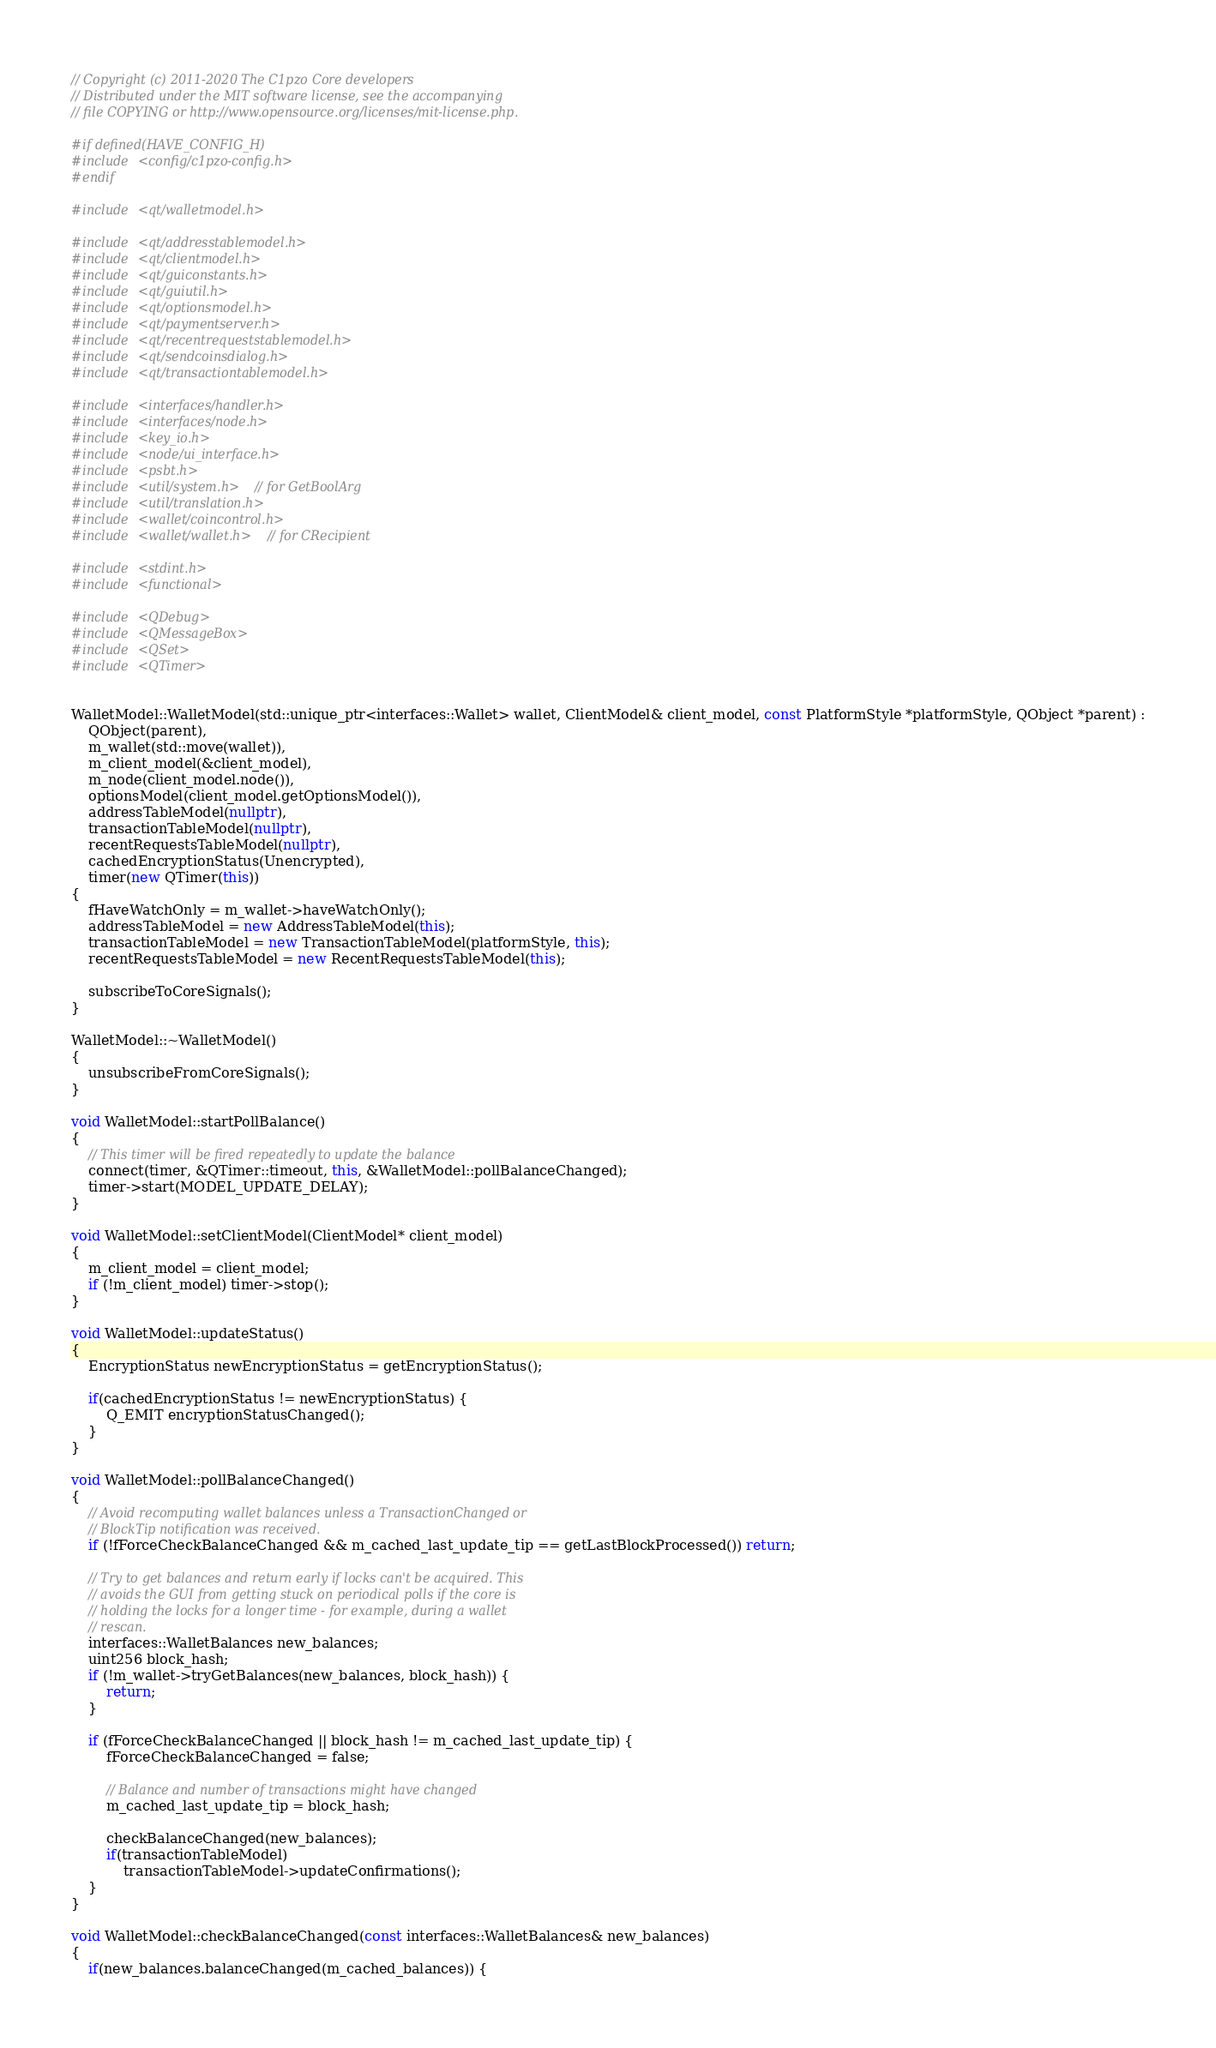<code> <loc_0><loc_0><loc_500><loc_500><_C++_>// Copyright (c) 2011-2020 The C1pzo Core developers
// Distributed under the MIT software license, see the accompanying
// file COPYING or http://www.opensource.org/licenses/mit-license.php.

#if defined(HAVE_CONFIG_H)
#include <config/c1pzo-config.h>
#endif

#include <qt/walletmodel.h>

#include <qt/addresstablemodel.h>
#include <qt/clientmodel.h>
#include <qt/guiconstants.h>
#include <qt/guiutil.h>
#include <qt/optionsmodel.h>
#include <qt/paymentserver.h>
#include <qt/recentrequeststablemodel.h>
#include <qt/sendcoinsdialog.h>
#include <qt/transactiontablemodel.h>

#include <interfaces/handler.h>
#include <interfaces/node.h>
#include <key_io.h>
#include <node/ui_interface.h>
#include <psbt.h>
#include <util/system.h> // for GetBoolArg
#include <util/translation.h>
#include <wallet/coincontrol.h>
#include <wallet/wallet.h> // for CRecipient

#include <stdint.h>
#include <functional>

#include <QDebug>
#include <QMessageBox>
#include <QSet>
#include <QTimer>


WalletModel::WalletModel(std::unique_ptr<interfaces::Wallet> wallet, ClientModel& client_model, const PlatformStyle *platformStyle, QObject *parent) :
    QObject(parent),
    m_wallet(std::move(wallet)),
    m_client_model(&client_model),
    m_node(client_model.node()),
    optionsModel(client_model.getOptionsModel()),
    addressTableModel(nullptr),
    transactionTableModel(nullptr),
    recentRequestsTableModel(nullptr),
    cachedEncryptionStatus(Unencrypted),
    timer(new QTimer(this))
{
    fHaveWatchOnly = m_wallet->haveWatchOnly();
    addressTableModel = new AddressTableModel(this);
    transactionTableModel = new TransactionTableModel(platformStyle, this);
    recentRequestsTableModel = new RecentRequestsTableModel(this);

    subscribeToCoreSignals();
}

WalletModel::~WalletModel()
{
    unsubscribeFromCoreSignals();
}

void WalletModel::startPollBalance()
{
    // This timer will be fired repeatedly to update the balance
    connect(timer, &QTimer::timeout, this, &WalletModel::pollBalanceChanged);
    timer->start(MODEL_UPDATE_DELAY);
}

void WalletModel::setClientModel(ClientModel* client_model)
{
    m_client_model = client_model;
    if (!m_client_model) timer->stop();
}

void WalletModel::updateStatus()
{
    EncryptionStatus newEncryptionStatus = getEncryptionStatus();

    if(cachedEncryptionStatus != newEncryptionStatus) {
        Q_EMIT encryptionStatusChanged();
    }
}

void WalletModel::pollBalanceChanged()
{
    // Avoid recomputing wallet balances unless a TransactionChanged or
    // BlockTip notification was received.
    if (!fForceCheckBalanceChanged && m_cached_last_update_tip == getLastBlockProcessed()) return;

    // Try to get balances and return early if locks can't be acquired. This
    // avoids the GUI from getting stuck on periodical polls if the core is
    // holding the locks for a longer time - for example, during a wallet
    // rescan.
    interfaces::WalletBalances new_balances;
    uint256 block_hash;
    if (!m_wallet->tryGetBalances(new_balances, block_hash)) {
        return;
    }

    if (fForceCheckBalanceChanged || block_hash != m_cached_last_update_tip) {
        fForceCheckBalanceChanged = false;

        // Balance and number of transactions might have changed
        m_cached_last_update_tip = block_hash;

        checkBalanceChanged(new_balances);
        if(transactionTableModel)
            transactionTableModel->updateConfirmations();
    }
}

void WalletModel::checkBalanceChanged(const interfaces::WalletBalances& new_balances)
{
    if(new_balances.balanceChanged(m_cached_balances)) {</code> 